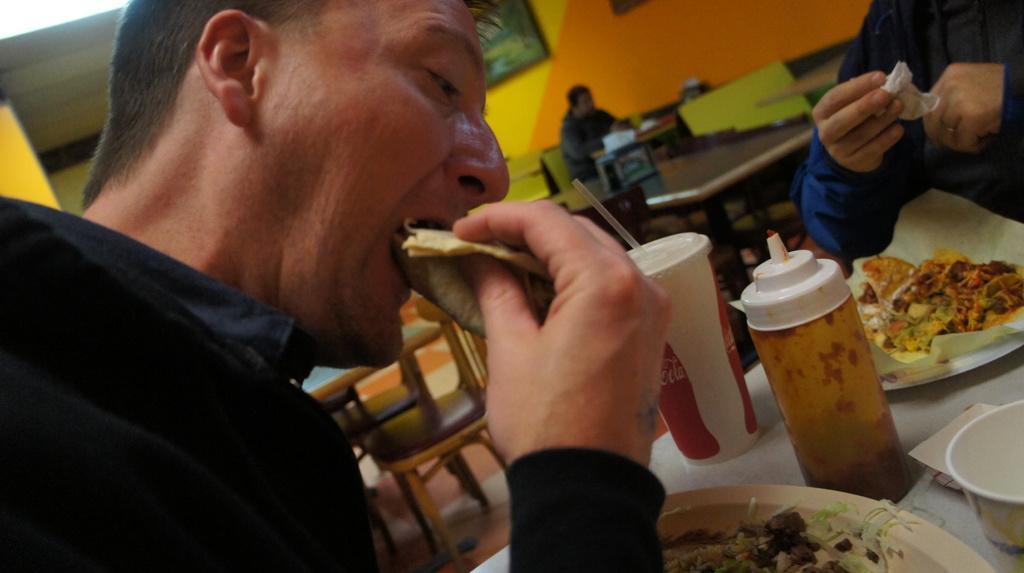Could you give a brief overview of what you see in this image? In this picture we can see a person eating the food. We can see another person holding a tissue paper in his hand. And some. There is a cup, bottle, bowl and some food on plates. There is a person sitting at the back. We can see a few benches and a chair. A frame is visible on the wall. 